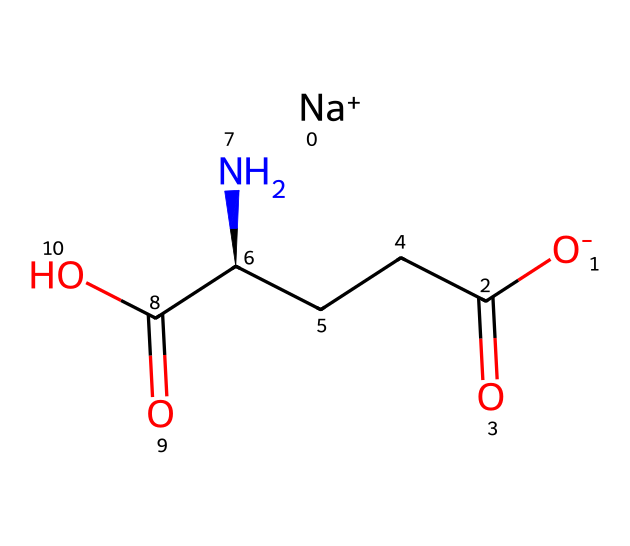What is the molecular formula of monosodium glutamate? To determine the molecular formula, we identify each type of atom present in the SMILES representation. The structure includes 1 sodium (Na), 5 carbon (C) atoms, 8 hydrogen (H) atoms, 2 nitrogen (N) atoms, and 4 oxygen (O) atoms. Combining these gives the formula: C5H8N1O4Na.
Answer: C5H8N1O4Na How many functional groups are present in monosodium glutamate? By examining the structure represented in the SMILES, we can identify functional groups: there are two carboxylic acid groups (-COOH), one amine group (-NH2), and a sodium ion (Na+). This totals four functional groups - two -COOH and one -NH2, plus the Na+.
Answer: four Which part of the structure contributes to the taste enhancement property of MSG? The taste enhancement property of MSG is primarily due to the amino group (-NH2) and the carboxylic acid groups (-COOH) that interact with taste receptors. The carboxylic acids and amino groups facilitate umami flavor perception.
Answer: amino group and carboxylic acid groups What is the charge of the sodium ion in monosodium glutamate? The sodium ion (Na+) carries a positive charge, which can be seen as part of the overall structure denoted in the SMILES.
Answer: positive Does monosodium glutamate contain chiral centers? Yes, the chemical structure exhibits chirality at the carbon atom connected to the amine group. This is determined by the presence of four different substituents attached to that carbon, making it a chiral center.
Answer: yes How many nitrogen atoms are present in monosodium glutamate? The SMILES notation includes one nitrogen in the amine group and another in the internal carbon chain, thus indicating the presence of two nitrogen atoms.
Answer: two 